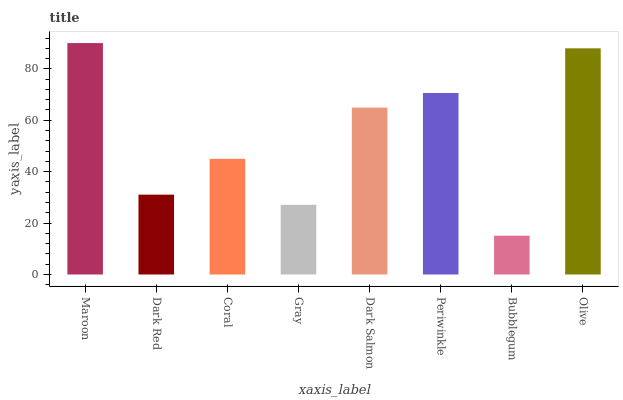Is Bubblegum the minimum?
Answer yes or no. Yes. Is Maroon the maximum?
Answer yes or no. Yes. Is Dark Red the minimum?
Answer yes or no. No. Is Dark Red the maximum?
Answer yes or no. No. Is Maroon greater than Dark Red?
Answer yes or no. Yes. Is Dark Red less than Maroon?
Answer yes or no. Yes. Is Dark Red greater than Maroon?
Answer yes or no. No. Is Maroon less than Dark Red?
Answer yes or no. No. Is Dark Salmon the high median?
Answer yes or no. Yes. Is Coral the low median?
Answer yes or no. Yes. Is Dark Red the high median?
Answer yes or no. No. Is Maroon the low median?
Answer yes or no. No. 